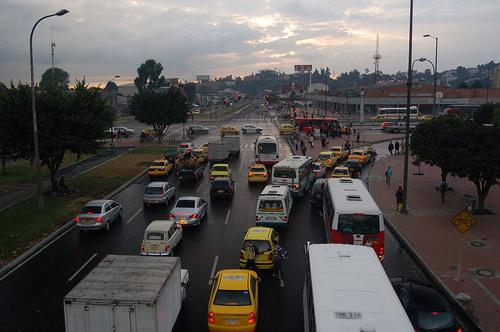What picture is on the sign that is all the way to the right? Please explain your reasoning. bicycle. The picture is a bike. 